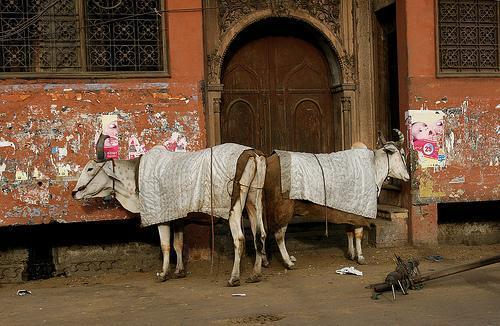How many goat are there?
Give a very brief answer. 2. 